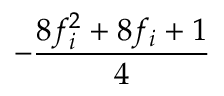Convert formula to latex. <formula><loc_0><loc_0><loc_500><loc_500>- \frac { 8 f _ { i } ^ { 2 } + 8 f _ { i } + 1 } { 4 }</formula> 